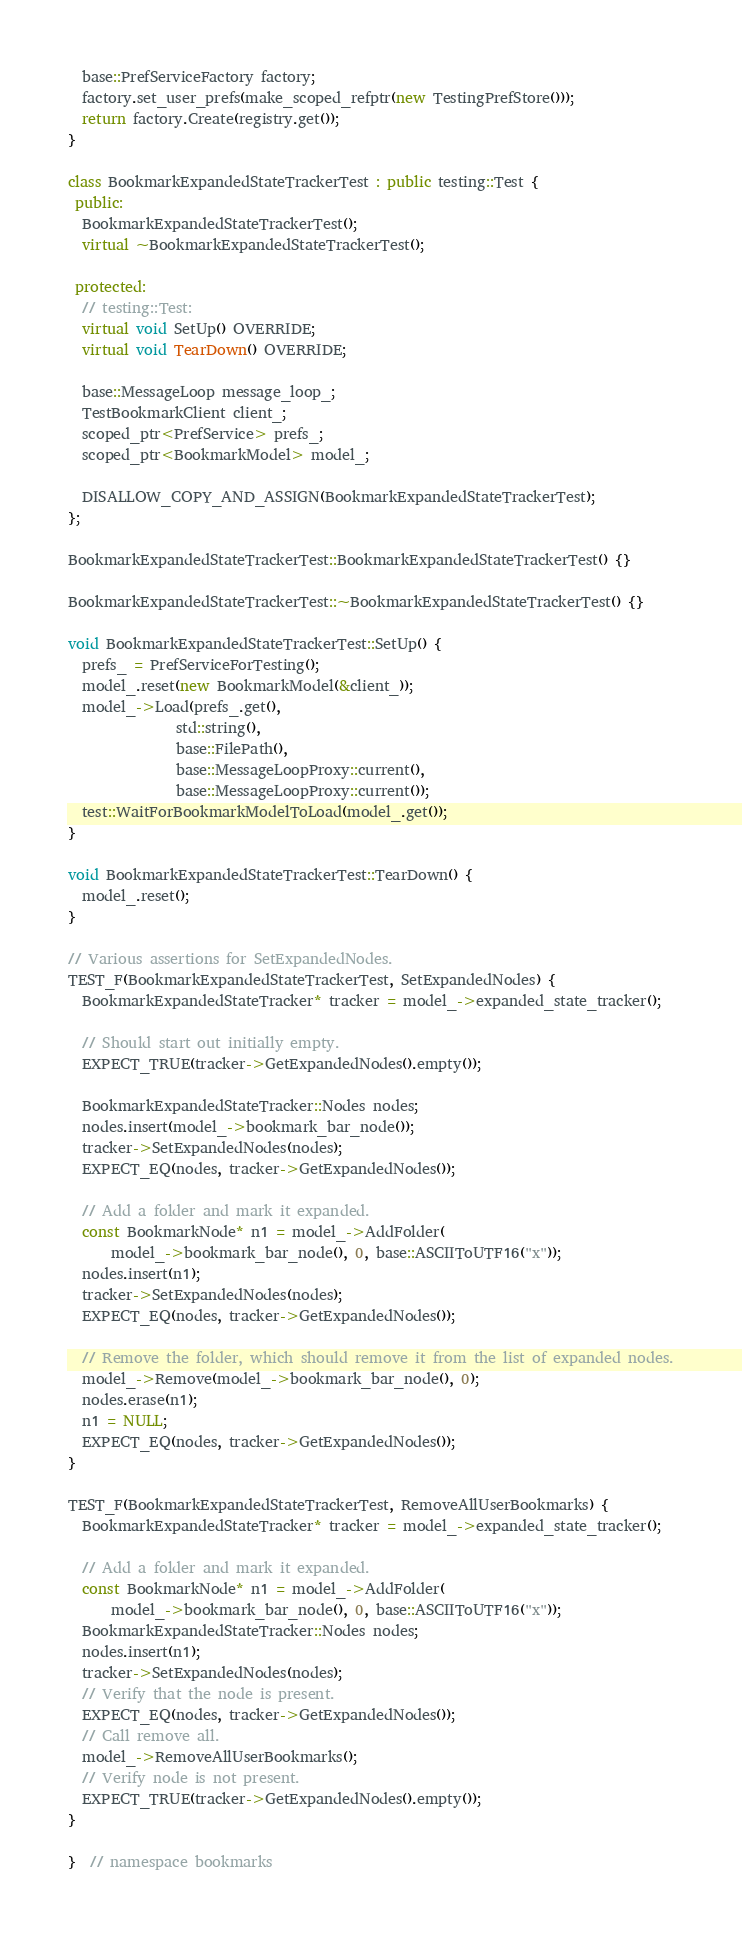Convert code to text. <code><loc_0><loc_0><loc_500><loc_500><_C++_>  base::PrefServiceFactory factory;
  factory.set_user_prefs(make_scoped_refptr(new TestingPrefStore()));
  return factory.Create(registry.get());
}

class BookmarkExpandedStateTrackerTest : public testing::Test {
 public:
  BookmarkExpandedStateTrackerTest();
  virtual ~BookmarkExpandedStateTrackerTest();

 protected:
  // testing::Test:
  virtual void SetUp() OVERRIDE;
  virtual void TearDown() OVERRIDE;

  base::MessageLoop message_loop_;
  TestBookmarkClient client_;
  scoped_ptr<PrefService> prefs_;
  scoped_ptr<BookmarkModel> model_;

  DISALLOW_COPY_AND_ASSIGN(BookmarkExpandedStateTrackerTest);
};

BookmarkExpandedStateTrackerTest::BookmarkExpandedStateTrackerTest() {}

BookmarkExpandedStateTrackerTest::~BookmarkExpandedStateTrackerTest() {}

void BookmarkExpandedStateTrackerTest::SetUp() {
  prefs_ = PrefServiceForTesting();
  model_.reset(new BookmarkModel(&client_));
  model_->Load(prefs_.get(),
               std::string(),
               base::FilePath(),
               base::MessageLoopProxy::current(),
               base::MessageLoopProxy::current());
  test::WaitForBookmarkModelToLoad(model_.get());
}

void BookmarkExpandedStateTrackerTest::TearDown() {
  model_.reset();
}

// Various assertions for SetExpandedNodes.
TEST_F(BookmarkExpandedStateTrackerTest, SetExpandedNodes) {
  BookmarkExpandedStateTracker* tracker = model_->expanded_state_tracker();

  // Should start out initially empty.
  EXPECT_TRUE(tracker->GetExpandedNodes().empty());

  BookmarkExpandedStateTracker::Nodes nodes;
  nodes.insert(model_->bookmark_bar_node());
  tracker->SetExpandedNodes(nodes);
  EXPECT_EQ(nodes, tracker->GetExpandedNodes());

  // Add a folder and mark it expanded.
  const BookmarkNode* n1 = model_->AddFolder(
      model_->bookmark_bar_node(), 0, base::ASCIIToUTF16("x"));
  nodes.insert(n1);
  tracker->SetExpandedNodes(nodes);
  EXPECT_EQ(nodes, tracker->GetExpandedNodes());

  // Remove the folder, which should remove it from the list of expanded nodes.
  model_->Remove(model_->bookmark_bar_node(), 0);
  nodes.erase(n1);
  n1 = NULL;
  EXPECT_EQ(nodes, tracker->GetExpandedNodes());
}

TEST_F(BookmarkExpandedStateTrackerTest, RemoveAllUserBookmarks) {
  BookmarkExpandedStateTracker* tracker = model_->expanded_state_tracker();

  // Add a folder and mark it expanded.
  const BookmarkNode* n1 = model_->AddFolder(
      model_->bookmark_bar_node(), 0, base::ASCIIToUTF16("x"));
  BookmarkExpandedStateTracker::Nodes nodes;
  nodes.insert(n1);
  tracker->SetExpandedNodes(nodes);
  // Verify that the node is present.
  EXPECT_EQ(nodes, tracker->GetExpandedNodes());
  // Call remove all.
  model_->RemoveAllUserBookmarks();
  // Verify node is not present.
  EXPECT_TRUE(tracker->GetExpandedNodes().empty());
}

}  // namespace bookmarks
</code> 